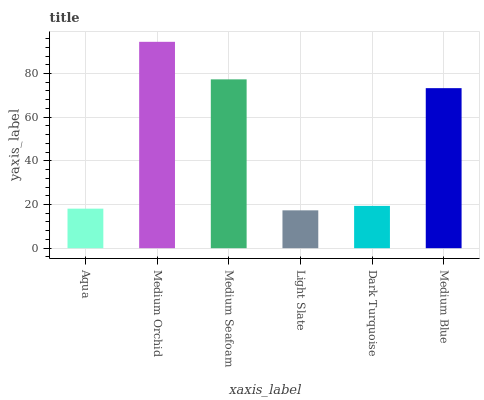Is Light Slate the minimum?
Answer yes or no. Yes. Is Medium Orchid the maximum?
Answer yes or no. Yes. Is Medium Seafoam the minimum?
Answer yes or no. No. Is Medium Seafoam the maximum?
Answer yes or no. No. Is Medium Orchid greater than Medium Seafoam?
Answer yes or no. Yes. Is Medium Seafoam less than Medium Orchid?
Answer yes or no. Yes. Is Medium Seafoam greater than Medium Orchid?
Answer yes or no. No. Is Medium Orchid less than Medium Seafoam?
Answer yes or no. No. Is Medium Blue the high median?
Answer yes or no. Yes. Is Dark Turquoise the low median?
Answer yes or no. Yes. Is Medium Seafoam the high median?
Answer yes or no. No. Is Medium Blue the low median?
Answer yes or no. No. 